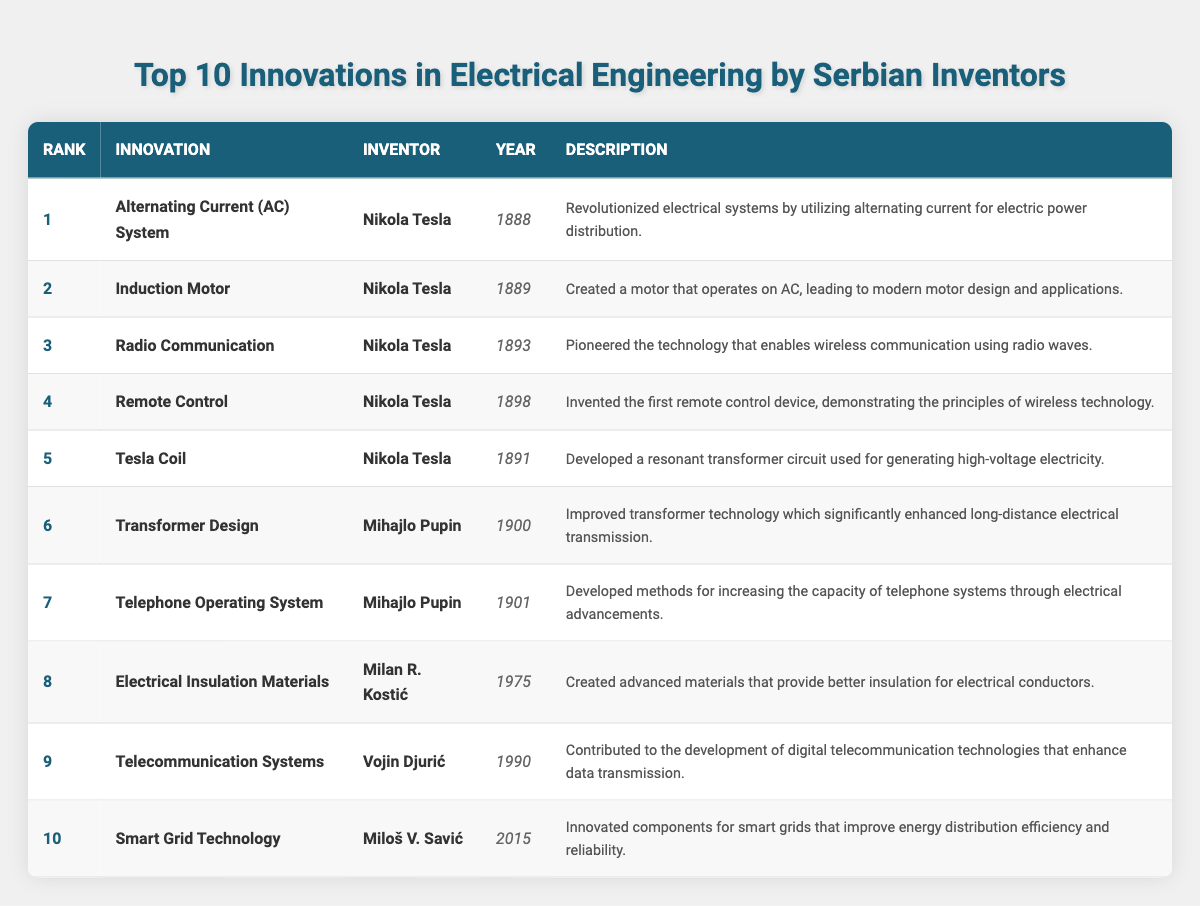What innovation was developed by Nikola Tesla in 1888? According to the table, Nikola Tesla developed the "Alternating Current (AC) System" in 1888.
Answer: Alternating Current (AC) System Which inventor is credited with the creation of the Induction Motor? The table specifies that the "Induction Motor" was created by Nikola Tesla.
Answer: Nikola Tesla What year was the first Remote Control invented? The table indicates that the "Remote Control" was invented in 1898.
Answer: 1898 How many innovations were created by Mihajlo Pupin? Mihajlo Pupin has two entries in the table: "Transformer Design" and "Telephone Operating System." Thus, he created 2 innovations.
Answer: 2 Which innovation came last in the chronological order based on the table? The innovation that came last in the chronological order is "Smart Grid Technology," which was developed in 2015.
Answer: Smart Grid Technology Did Milan R. Kostić contribute to the field of electrical insulation? Yes, the table states that Milan R. Kostić created "Electrical Insulation Materials."
Answer: Yes What is the difference in years between the invention of the Tesla Coil and the development of Smart Grid Technology? The Tesla Coil was invented in 1891 and Smart Grid Technology was developed in 2015. The difference is 2015 - 1891 = 124 years.
Answer: 124 years How many years separate the invention of the Induction Motor and the invention of Electrical Insulation Materials? The Induction Motor was invented in 1889 and Electrical Insulation Materials in 1975. The difference is 1975 - 1889 = 86 years.
Answer: 86 years Which innovation has the earliest date of invention and who is the inventor? The earliest date of invention is 1888 for the "Alternating Current (AC) System," and the inventor is Nikola Tesla.
Answer: Alternating Current (AC) System, Nikola Tesla Is it true that Vojin Djurić invented a technology related to digital telecommunication? The table confirms that Vojin Djurić contributed to "Telecommunication Systems," which indeed relates to digital telecommunication technologies.
Answer: True 